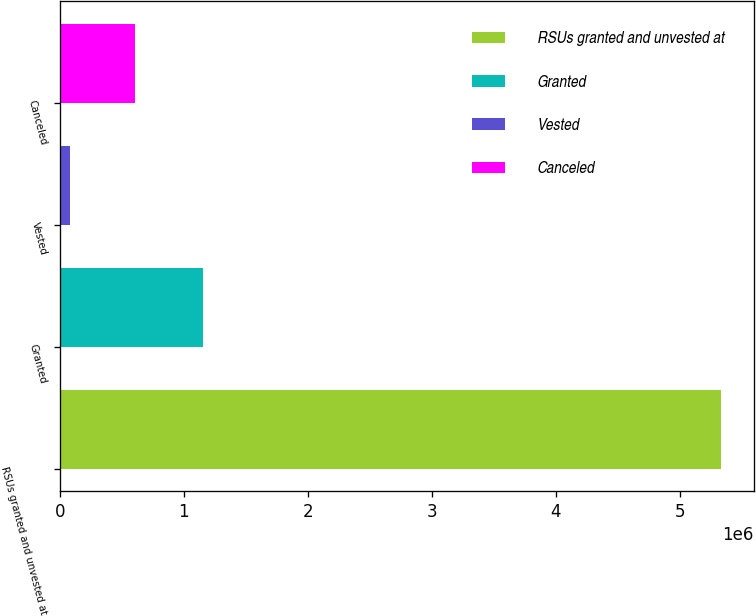Convert chart to OTSL. <chart><loc_0><loc_0><loc_500><loc_500><bar_chart><fcel>RSUs granted and unvested at<fcel>Granted<fcel>Vested<fcel>Canceled<nl><fcel>5.33044e+06<fcel>1.15495e+06<fcel>81500<fcel>606394<nl></chart> 